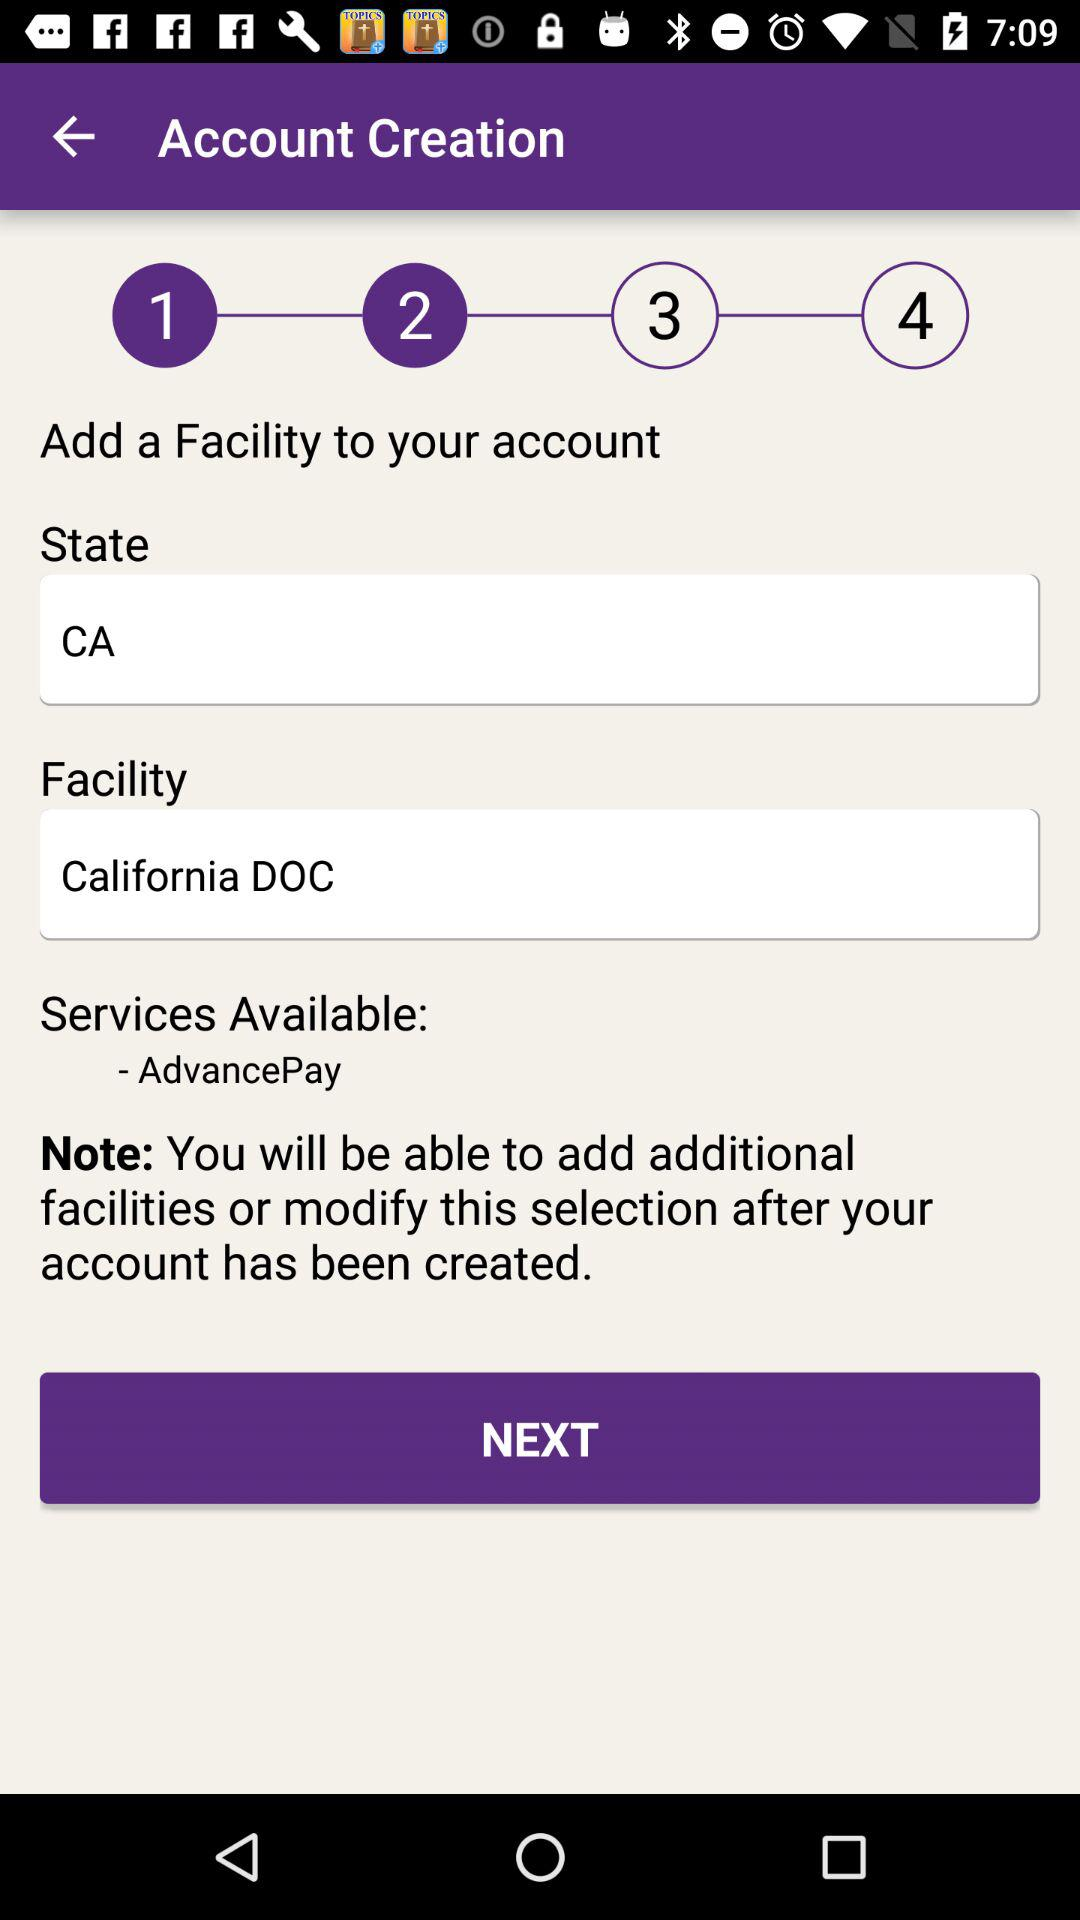What are the available services? The available service is "AdvancePay". 